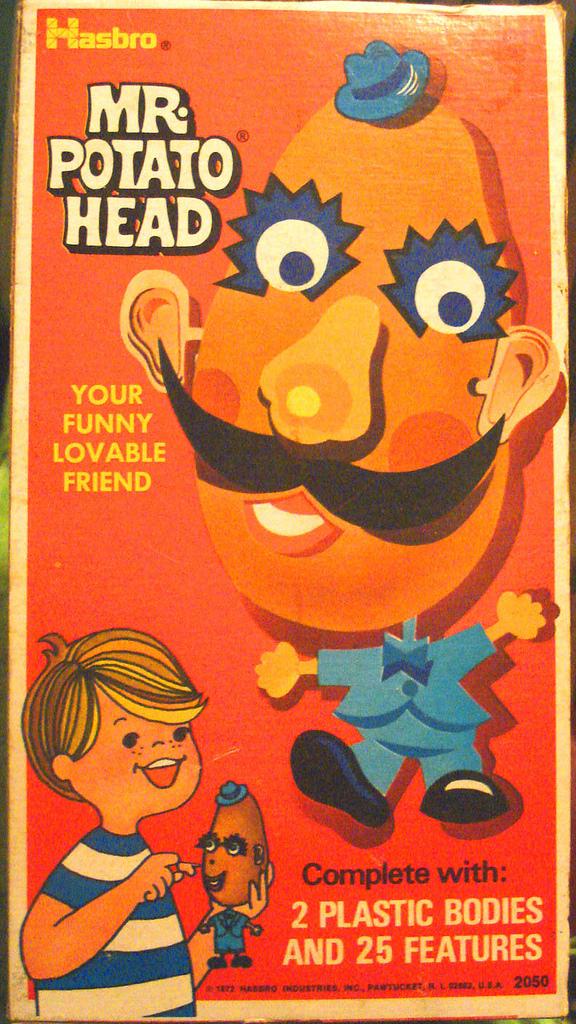How many features?
Give a very brief answer. 25. How many bodies?
Your response must be concise. 2. 